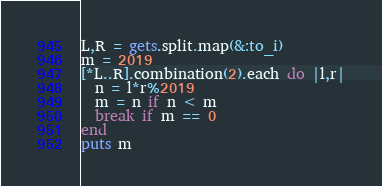<code> <loc_0><loc_0><loc_500><loc_500><_Ruby_>L,R = gets.split.map(&:to_i)
m = 2019
[*L..R].combination(2).each do |l,r|
  n = l*r%2019
  m = n if n < m
  break if m == 0
end
puts m</code> 